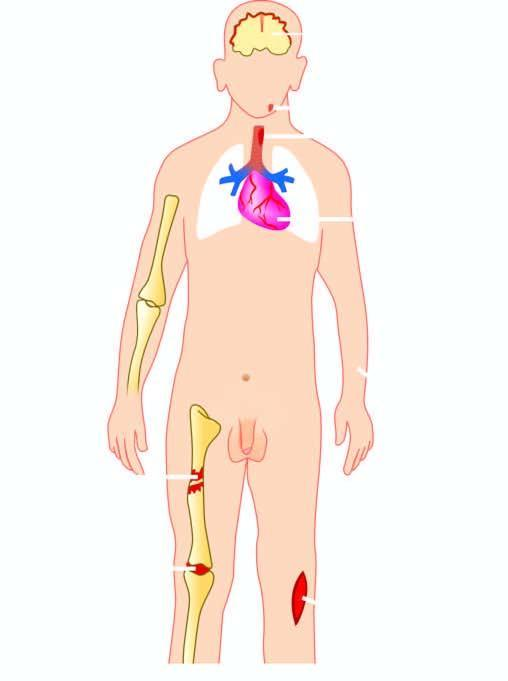s uppurative diseases caused by staphylococcus aureus?
Answer the question using a single word or phrase. Yes 